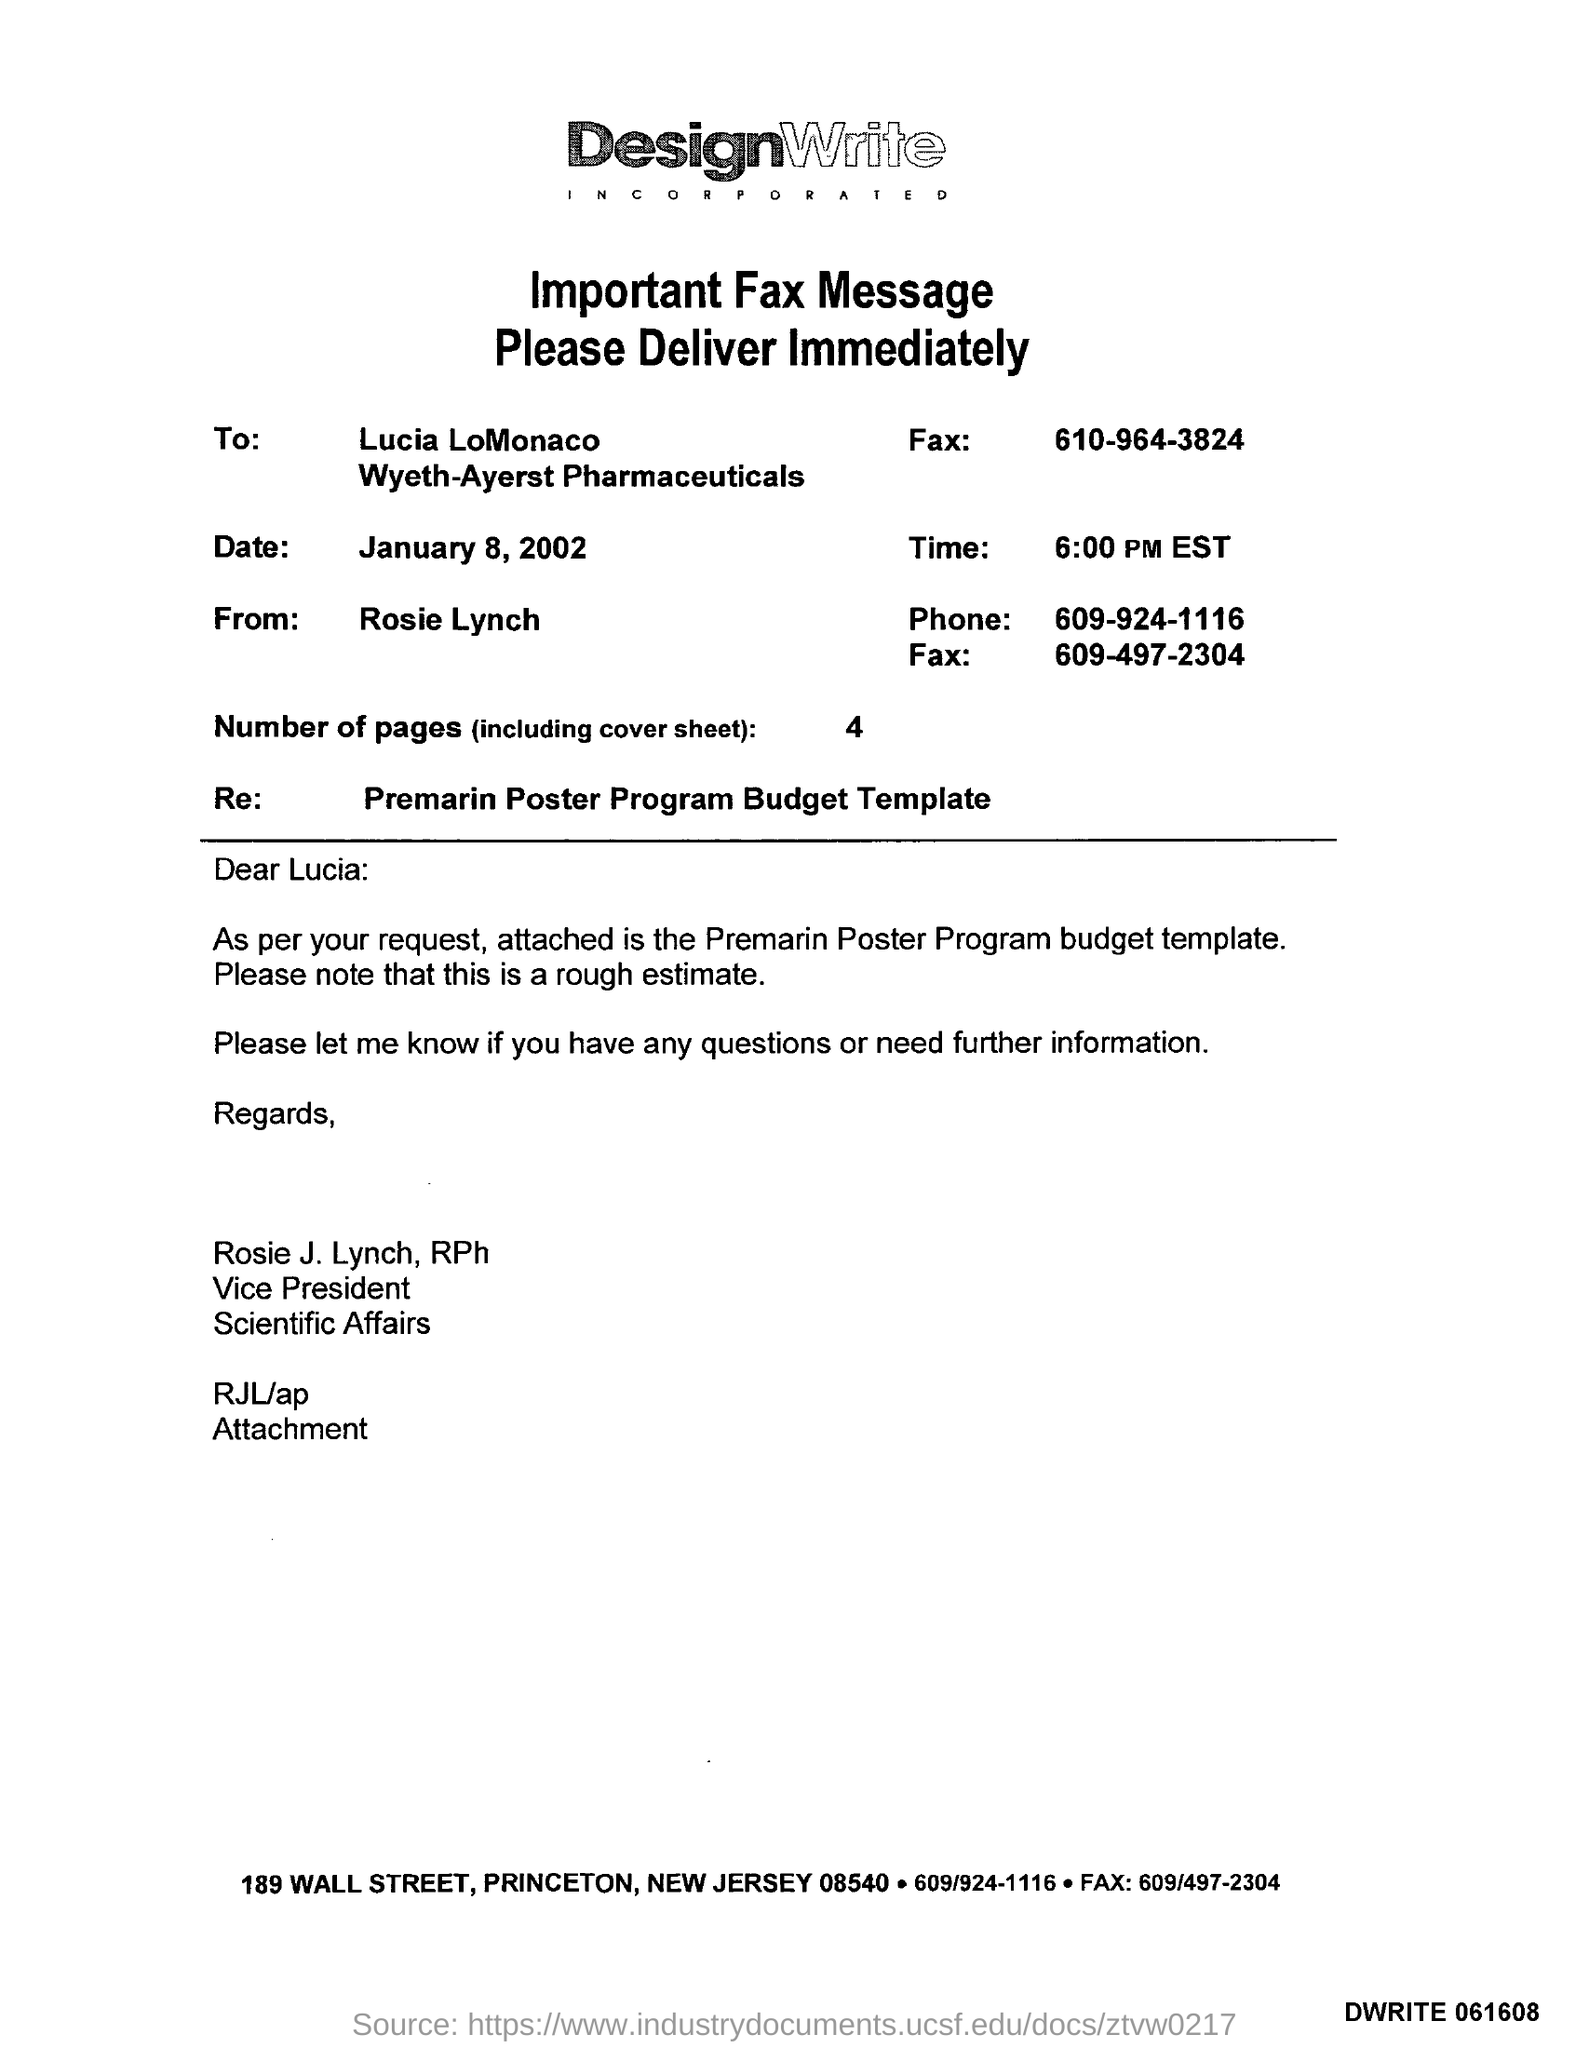To whom this fax message was sent ?
Make the answer very short. Lucia LoMonaco. What is the date mentioned in the fax message ?
Give a very brief answer. January 8 , 2002. From whom this fax message was delivered ?
Provide a succinct answer. Rosie Lynch. What is the time mentioned in the given fax message ?
Make the answer very short. 6:00 PM EST. How many number of pages are there (including cover sheet )?
Your response must be concise. 4. What is the phone number mentioned in the fax message ?
Provide a short and direct response. 609-924-1116. What is the re mentioned in the given fax message ?
Ensure brevity in your answer.  Premarin poster program budget template. 